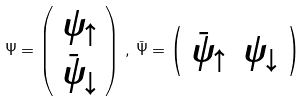<formula> <loc_0><loc_0><loc_500><loc_500>\Psi = \left ( \begin{array} { c } \psi _ { \uparrow } \\ \bar { \psi } _ { \downarrow } \end{array} \right ) \, , \, \bar { \Psi } = \left ( \begin{array} { c c } \bar { \psi } _ { \uparrow } & \psi _ { \downarrow } \end{array} \right )</formula> 